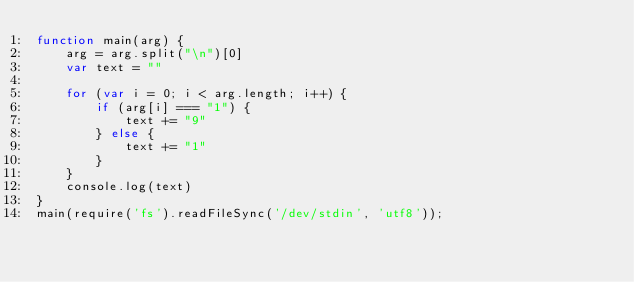Convert code to text. <code><loc_0><loc_0><loc_500><loc_500><_JavaScript_>function main(arg) {
	arg = arg.split("\n")[0]
	var text = ""

	for (var i = 0; i < arg.length; i++) {
		if (arg[i] === "1") {
			text += "9"
		} else {
			text += "1"
		}
	}
	console.log(text)
}
main(require('fs').readFileSync('/dev/stdin', 'utf8'));</code> 